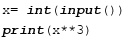Convert code to text. <code><loc_0><loc_0><loc_500><loc_500><_Python_>x= int(input())
print(x**3)
</code> 